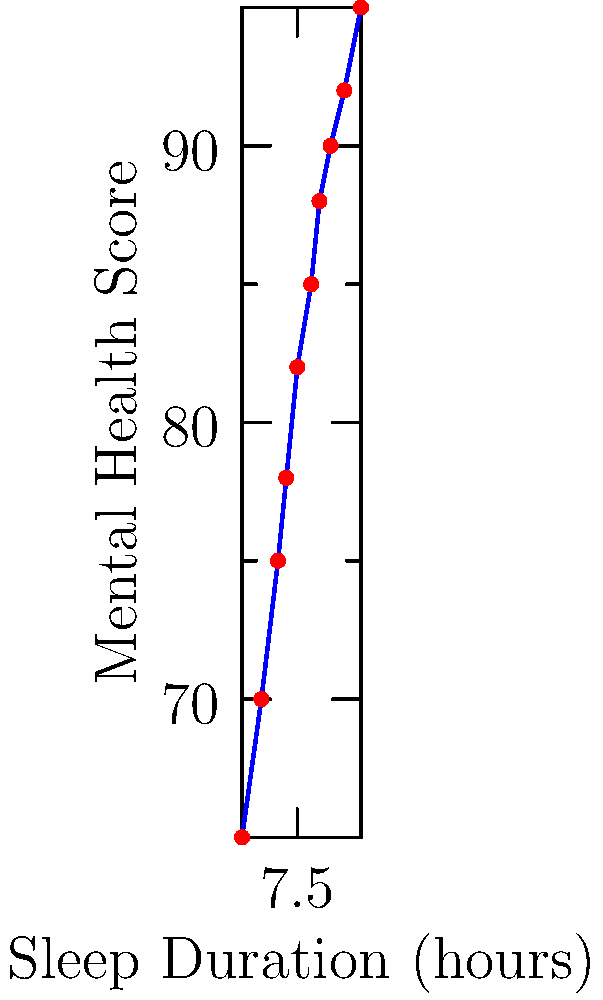Based on the scatter plot, which best describes the relationship between sleep duration and mental health scores? To analyze the relationship between sleep duration and mental health scores, we need to examine the pattern of the data points in the scatter plot:

1. Direction: As we move from left to right (increasing sleep duration), the mental health scores generally increase. This indicates a positive relationship.

2. Form: The points roughly follow a straight line, suggesting a linear relationship.

3. Strength: The points are clustered relatively close to an imaginary line we could draw through them, indicating a strong relationship.

4. Outliers: There don't appear to be any significant outliers that deviate from the general trend.

5. Slope: The line has a positive slope, confirming the positive relationship.

Given these observations, we can conclude that there is a strong, positive, linear relationship between sleep duration and mental health scores. As sleep duration increases, mental health scores tend to increase as well.

This relationship aligns with sleep research findings that adequate sleep is associated with better mental health outcomes.
Answer: Strong positive linear relationship 